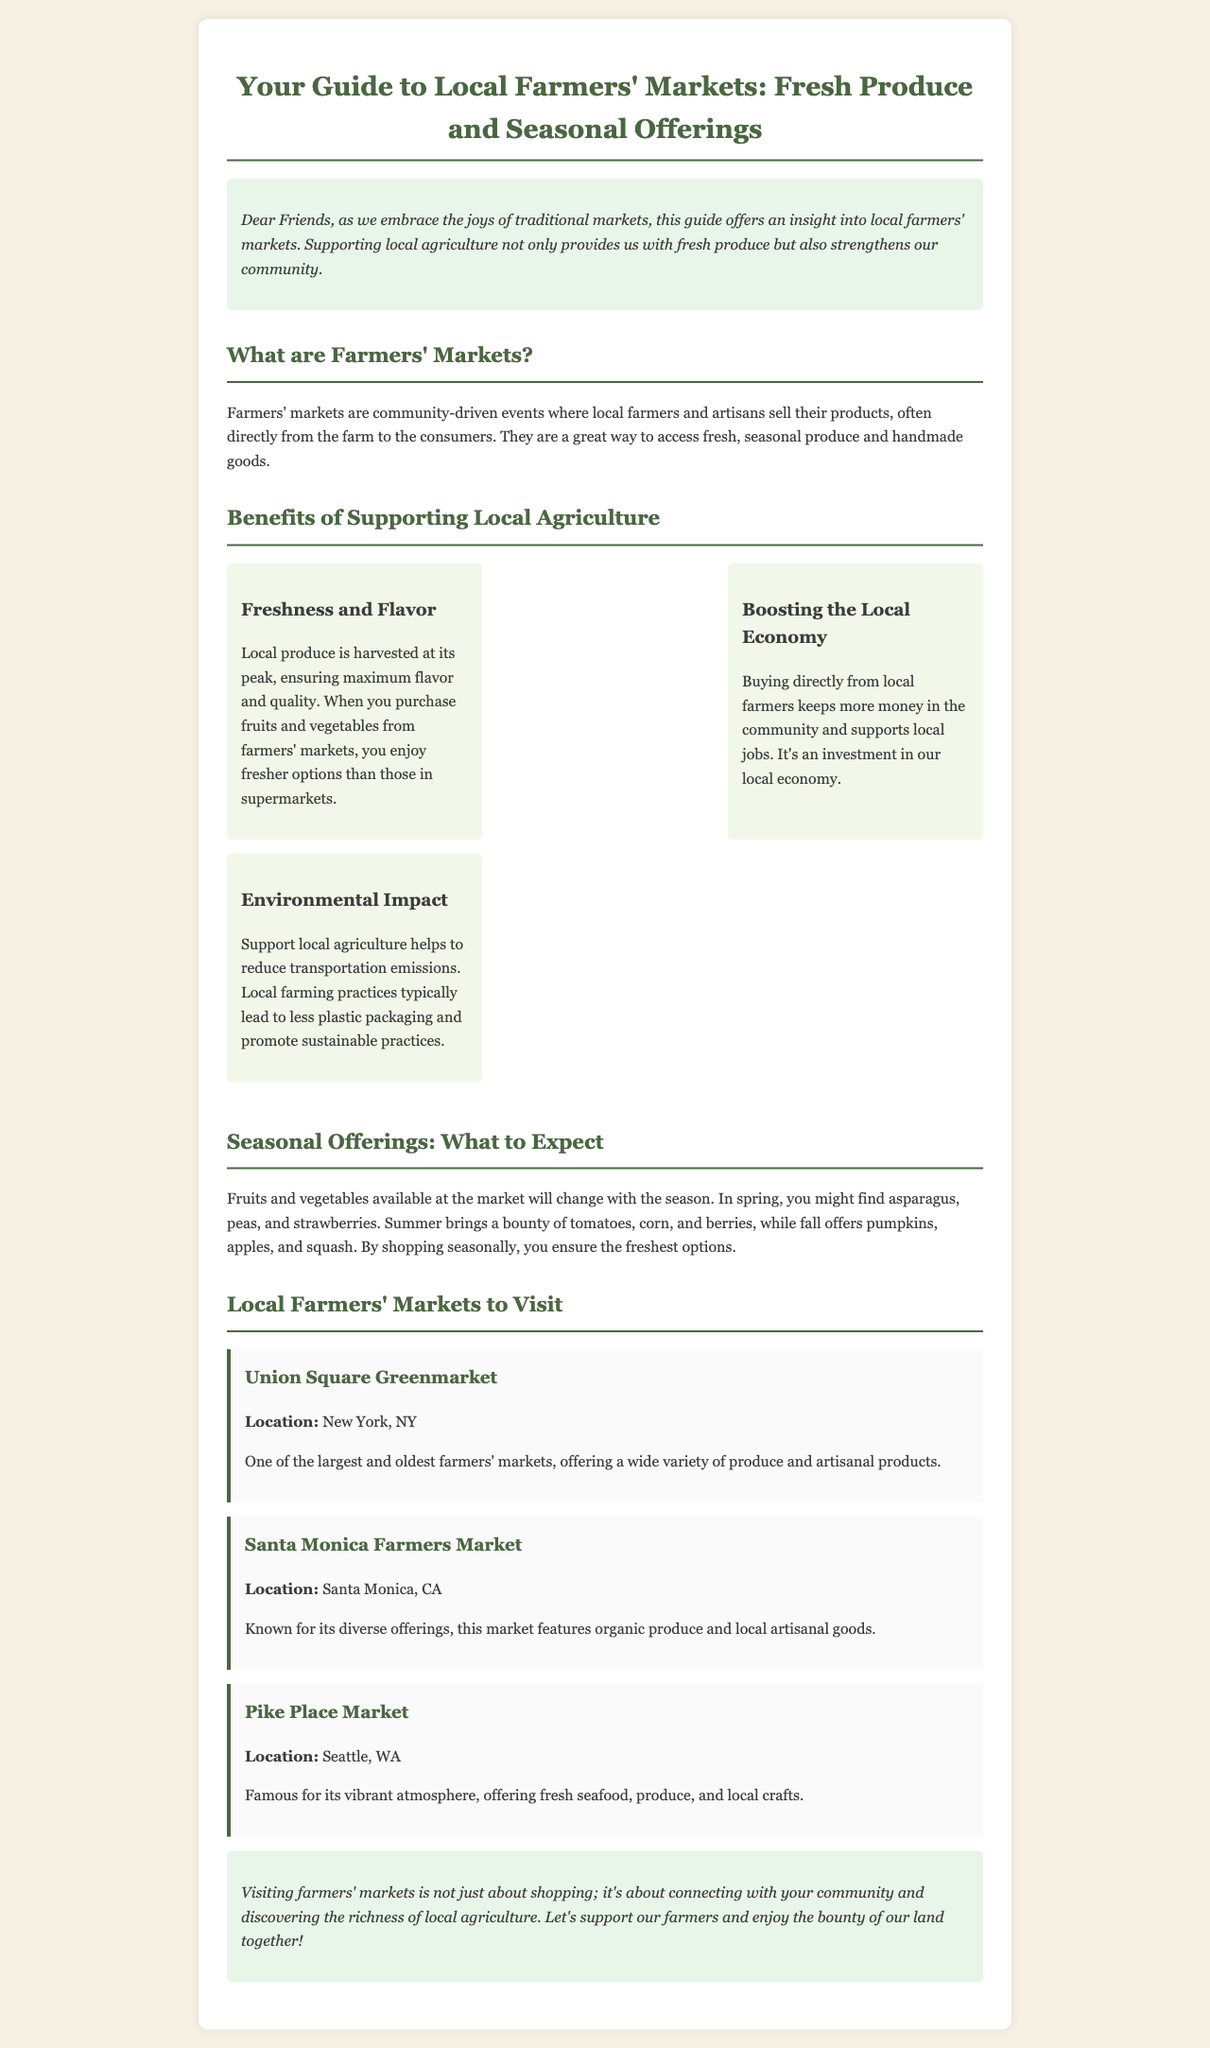What are farmers' markets? Farmers' markets are community-driven events where local farmers and artisans sell their products, often directly from the farm to the consumers.
Answer: Community-driven events What is one benefit of supporting local agriculture? The document lists three benefits, one of which is "Freshness and Flavor," ensuring maximum flavor and quality.
Answer: Freshness and Flavor What seasonal fruit is mentioned for spring? The document mentions strawberries as a seasonal offering in spring.
Answer: Strawberries How many local farmers' markets are listed in the document? There are three local farmers' markets mentioned in the document.
Answer: Three Where is the Union Square Greenmarket located? The location of the Union Square Greenmarket is specified in the document as New York, NY.
Answer: New York, NY What impact does supporting local agriculture have on the environment? The document states that it helps to reduce transportation emissions and promotes sustainable practices.
Answer: Reduces transportation emissions What is the focus of the newsletter? The newsletter provides a guide to local farmers' markets, fresh produce, and benefits of supporting local agriculture.
Answer: Local farmers' markets What type of offerings can one expect in the summer at farmers' markets? The document mentions tomatoes, corn, and berries as summer offerings.
Answer: Tomatoes, corn, and berries What is the overall message of the conclusion in the document? The conclusion emphasizes connecting with the community and supporting local farmers for their agricultural richness.
Answer: Connecting with the community 